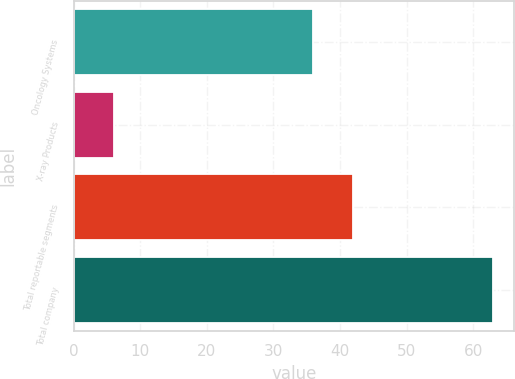<chart> <loc_0><loc_0><loc_500><loc_500><bar_chart><fcel>Oncology Systems<fcel>X-ray Products<fcel>Total reportable segments<fcel>Total company<nl><fcel>36<fcel>6<fcel>42<fcel>63<nl></chart> 